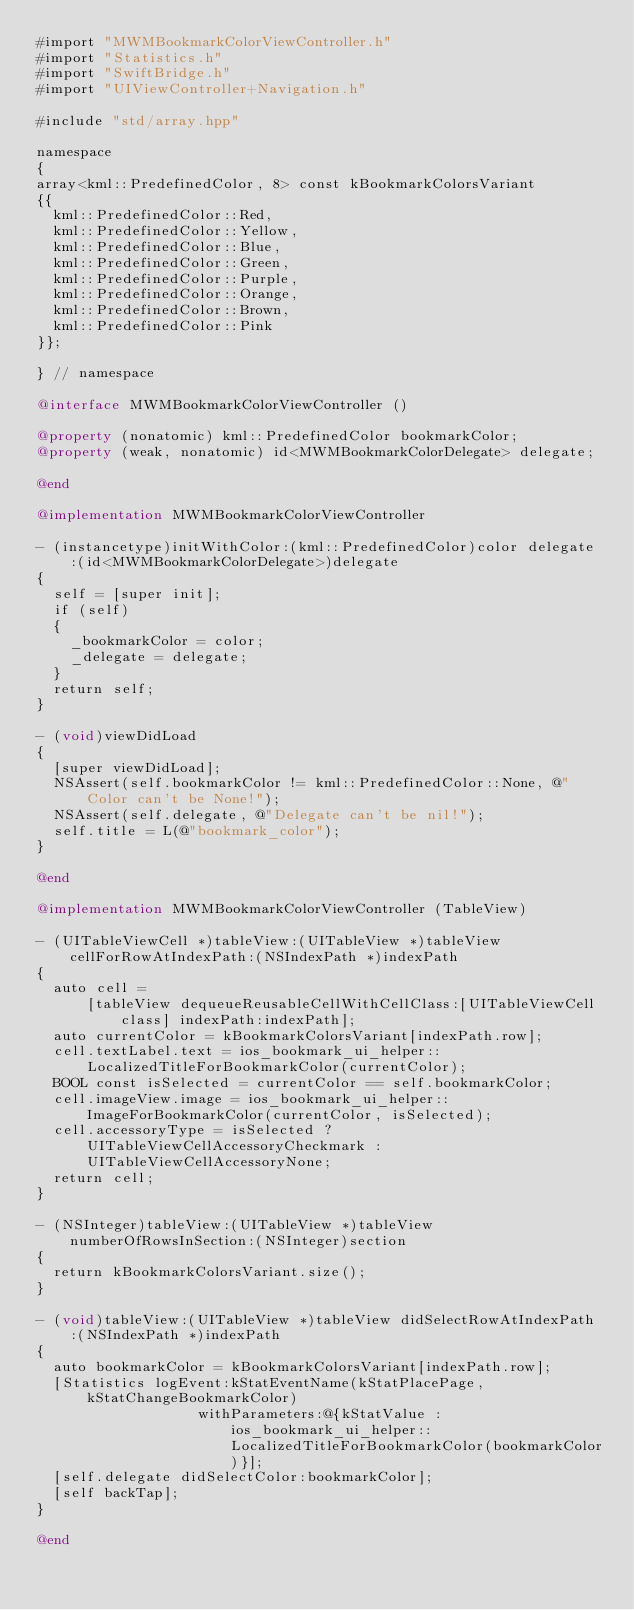<code> <loc_0><loc_0><loc_500><loc_500><_ObjectiveC_>#import "MWMBookmarkColorViewController.h"
#import "Statistics.h"
#import "SwiftBridge.h"
#import "UIViewController+Navigation.h"

#include "std/array.hpp"

namespace
{
array<kml::PredefinedColor, 8> const kBookmarkColorsVariant
{{
  kml::PredefinedColor::Red,
  kml::PredefinedColor::Yellow,
  kml::PredefinedColor::Blue,
  kml::PredefinedColor::Green,
  kml::PredefinedColor::Purple,
  kml::PredefinedColor::Orange,
  kml::PredefinedColor::Brown,
  kml::PredefinedColor::Pink
}};

} // namespace

@interface MWMBookmarkColorViewController ()

@property (nonatomic) kml::PredefinedColor bookmarkColor;
@property (weak, nonatomic) id<MWMBookmarkColorDelegate> delegate;

@end

@implementation MWMBookmarkColorViewController

- (instancetype)initWithColor:(kml::PredefinedColor)color delegate:(id<MWMBookmarkColorDelegate>)delegate
{
  self = [super init];
  if (self)
  {
    _bookmarkColor = color;
    _delegate = delegate;
  }
  return self;
}

- (void)viewDidLoad
{
  [super viewDidLoad];
  NSAssert(self.bookmarkColor != kml::PredefinedColor::None, @"Color can't be None!");
  NSAssert(self.delegate, @"Delegate can't be nil!");
  self.title = L(@"bookmark_color");
}

@end

@implementation MWMBookmarkColorViewController (TableView)

- (UITableViewCell *)tableView:(UITableView *)tableView cellForRowAtIndexPath:(NSIndexPath *)indexPath
{
  auto cell =
      [tableView dequeueReusableCellWithCellClass:[UITableViewCell class] indexPath:indexPath];
  auto currentColor = kBookmarkColorsVariant[indexPath.row];
  cell.textLabel.text = ios_bookmark_ui_helper::LocalizedTitleForBookmarkColor(currentColor);
  BOOL const isSelected = currentColor == self.bookmarkColor;
  cell.imageView.image = ios_bookmark_ui_helper::ImageForBookmarkColor(currentColor, isSelected);
  cell.accessoryType = isSelected ? UITableViewCellAccessoryCheckmark : UITableViewCellAccessoryNone;
  return cell;
}

- (NSInteger)tableView:(UITableView *)tableView numberOfRowsInSection:(NSInteger)section
{
  return kBookmarkColorsVariant.size();
}

- (void)tableView:(UITableView *)tableView didSelectRowAtIndexPath:(NSIndexPath *)indexPath
{
  auto bookmarkColor = kBookmarkColorsVariant[indexPath.row];
  [Statistics logEvent:kStatEventName(kStatPlacePage, kStatChangeBookmarkColor)
                   withParameters:@{kStatValue : ios_bookmark_ui_helper::LocalizedTitleForBookmarkColor(bookmarkColor)}];
  [self.delegate didSelectColor:bookmarkColor];
  [self backTap];
}

@end
</code> 